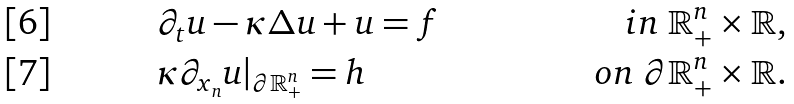Convert formula to latex. <formula><loc_0><loc_0><loc_500><loc_500>& \partial _ { t } u - \kappa \Delta u + u = f & i n \ \mathbb { R } ^ { n } _ { + } \times \mathbb { R } , \\ & \kappa \partial _ { x _ { n } } u | _ { \partial \mathbb { R } ^ { n } _ { + } } = h & o n \ \partial \mathbb { R } ^ { n } _ { + } \times \mathbb { R } .</formula> 